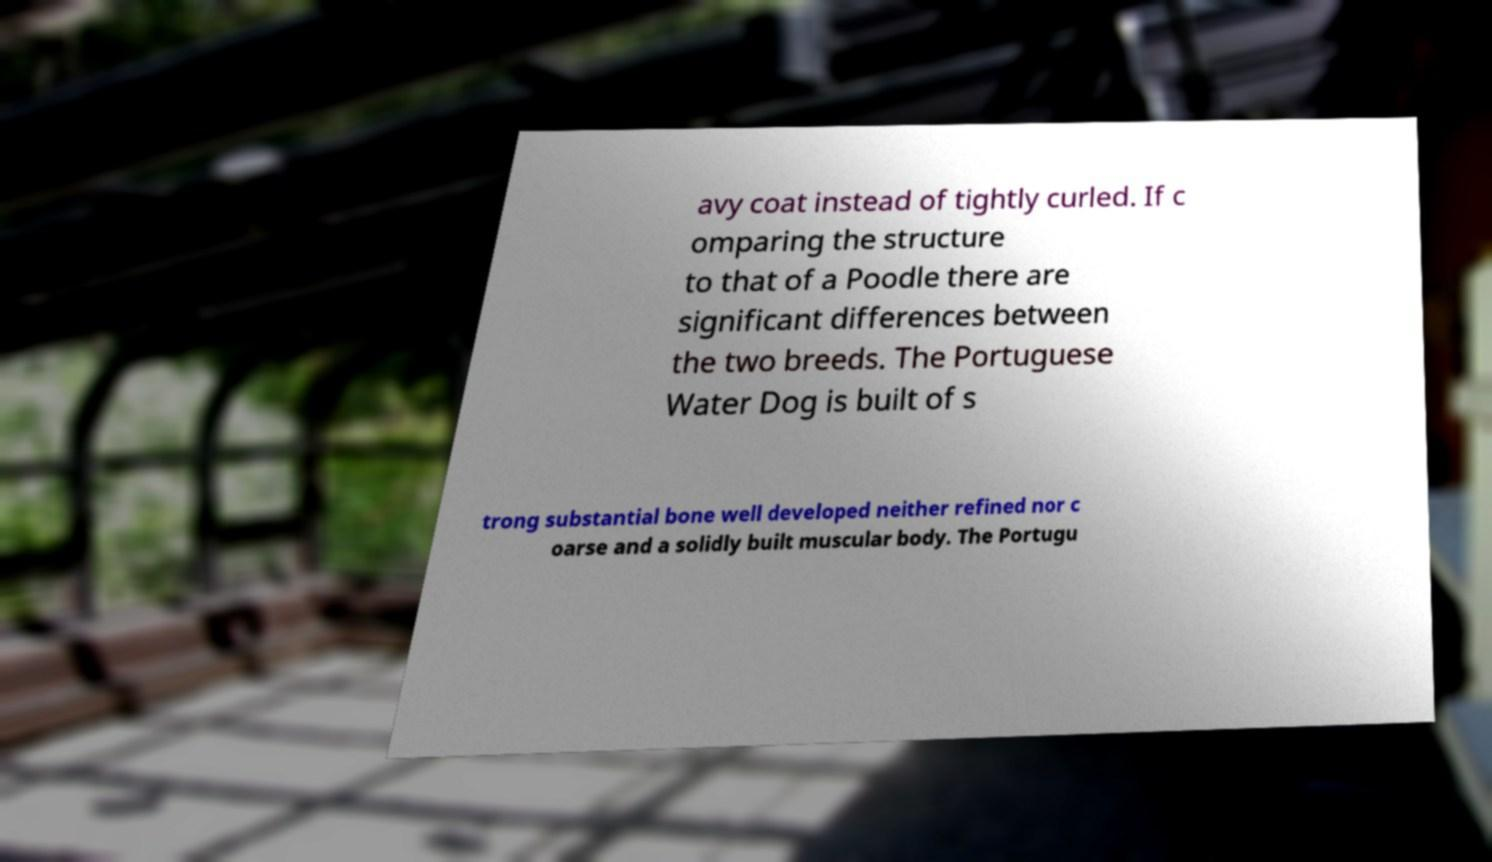What messages or text are displayed in this image? I need them in a readable, typed format. avy coat instead of tightly curled. If c omparing the structure to that of a Poodle there are significant differences between the two breeds. The Portuguese Water Dog is built of s trong substantial bone well developed neither refined nor c oarse and a solidly built muscular body. The Portugu 